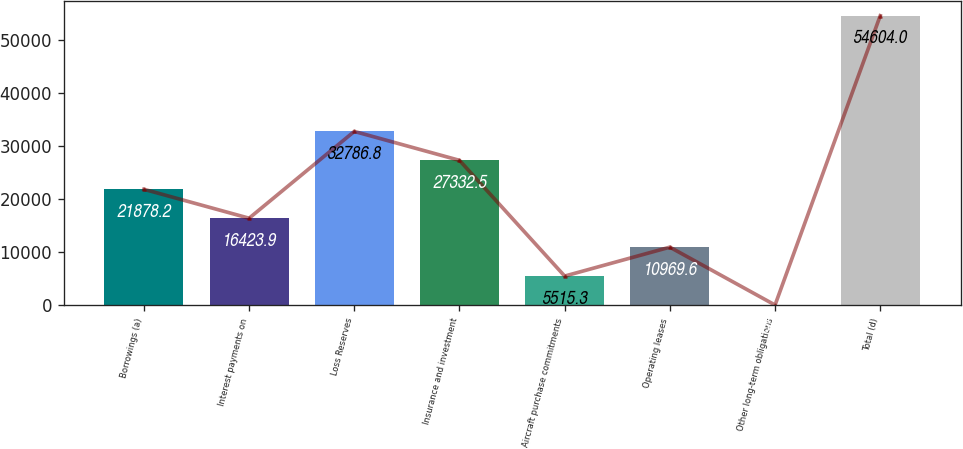Convert chart to OTSL. <chart><loc_0><loc_0><loc_500><loc_500><bar_chart><fcel>Borrowings (a)<fcel>Interest payments on<fcel>Loss Reserves<fcel>Insurance and investment<fcel>Aircraft purchase commitments<fcel>Operating leases<fcel>Other long-term obligations<fcel>Total (d)<nl><fcel>21878.2<fcel>16423.9<fcel>32786.8<fcel>27332.5<fcel>5515.3<fcel>10969.6<fcel>61<fcel>54604<nl></chart> 